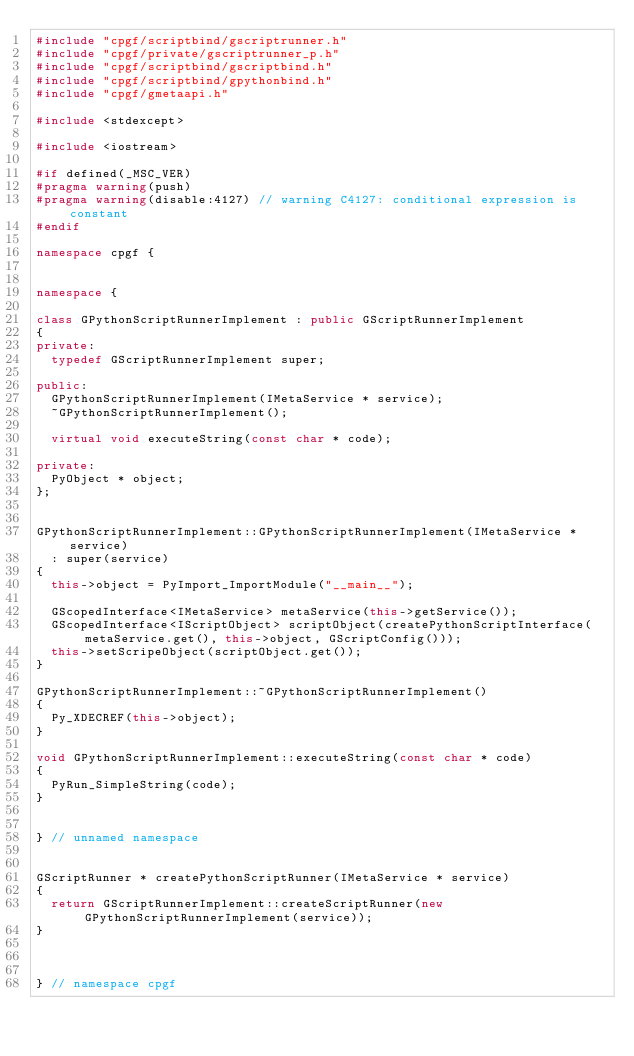Convert code to text. <code><loc_0><loc_0><loc_500><loc_500><_C++_>#include "cpgf/scriptbind/gscriptrunner.h"
#include "cpgf/private/gscriptrunner_p.h"
#include "cpgf/scriptbind/gscriptbind.h"
#include "cpgf/scriptbind/gpythonbind.h"
#include "cpgf/gmetaapi.h"

#include <stdexcept>

#include <iostream>

#if defined(_MSC_VER)
#pragma warning(push)
#pragma warning(disable:4127) // warning C4127: conditional expression is constant
#endif

namespace cpgf {


namespace {

class GPythonScriptRunnerImplement : public GScriptRunnerImplement
{
private:
	typedef GScriptRunnerImplement super;

public:
	GPythonScriptRunnerImplement(IMetaService * service);
	~GPythonScriptRunnerImplement();

	virtual void executeString(const char * code);

private:
	PyObject * object;
};


GPythonScriptRunnerImplement::GPythonScriptRunnerImplement(IMetaService * service)
	: super(service)
{
	this->object = PyImport_ImportModule("__main__");
	
	GScopedInterface<IMetaService> metaService(this->getService());
	GScopedInterface<IScriptObject> scriptObject(createPythonScriptInterface(metaService.get(), this->object, GScriptConfig()));
	this->setScripeObject(scriptObject.get());
}

GPythonScriptRunnerImplement::~GPythonScriptRunnerImplement()
{
	Py_XDECREF(this->object);
}

void GPythonScriptRunnerImplement::executeString(const char * code)
{
	PyRun_SimpleString(code);
}


} // unnamed namespace


GScriptRunner * createPythonScriptRunner(IMetaService * service)
{
	return GScriptRunnerImplement::createScriptRunner(new GPythonScriptRunnerImplement(service));
}



} // namespace cpgf
</code> 